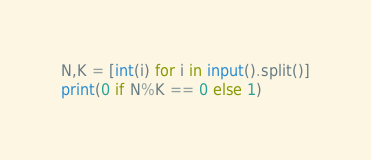Convert code to text. <code><loc_0><loc_0><loc_500><loc_500><_Python_>N,K = [int(i) for i in input().split()]
print(0 if N%K == 0 else 1)</code> 